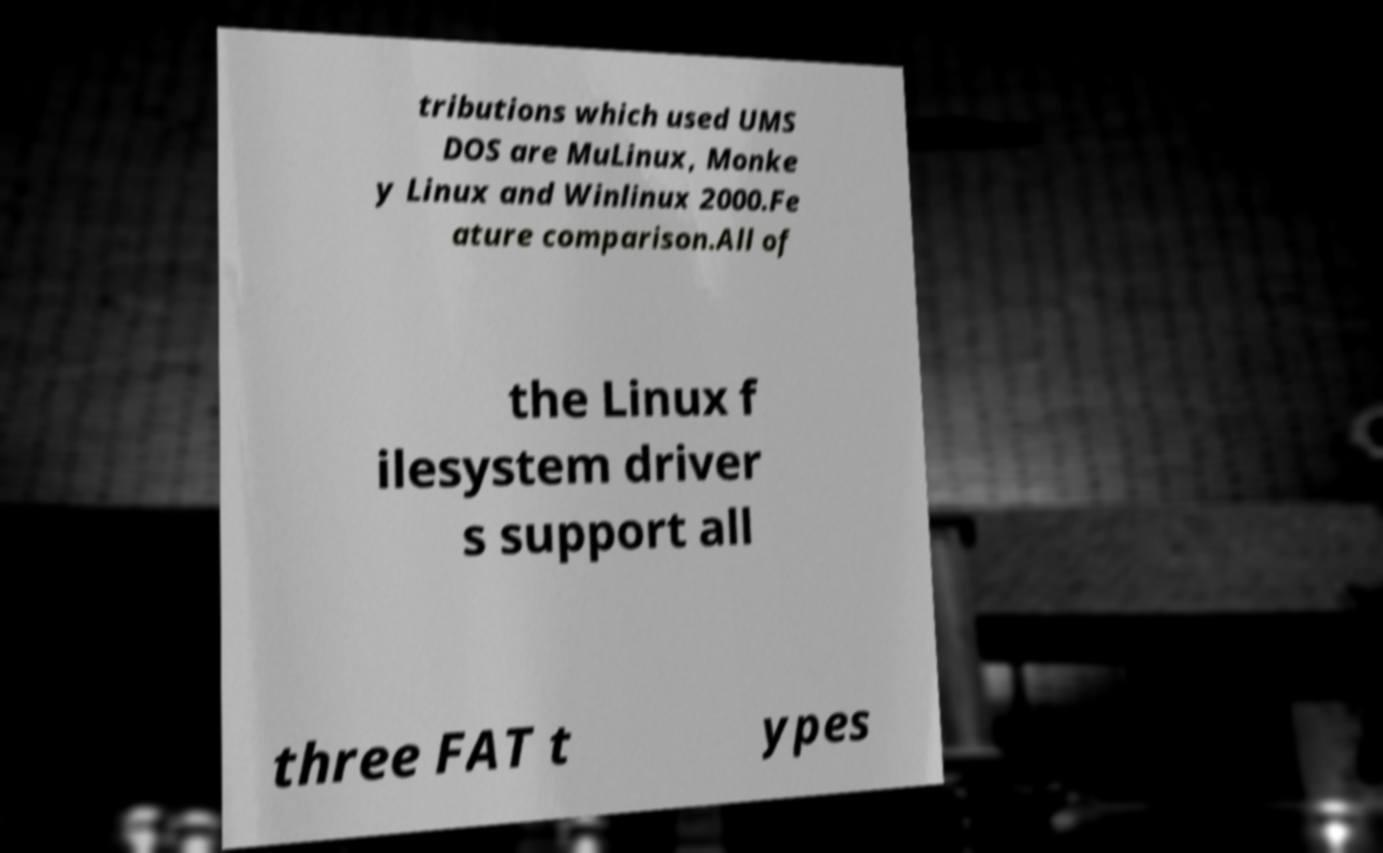What messages or text are displayed in this image? I need them in a readable, typed format. tributions which used UMS DOS are MuLinux, Monke y Linux and Winlinux 2000.Fe ature comparison.All of the Linux f ilesystem driver s support all three FAT t ypes 